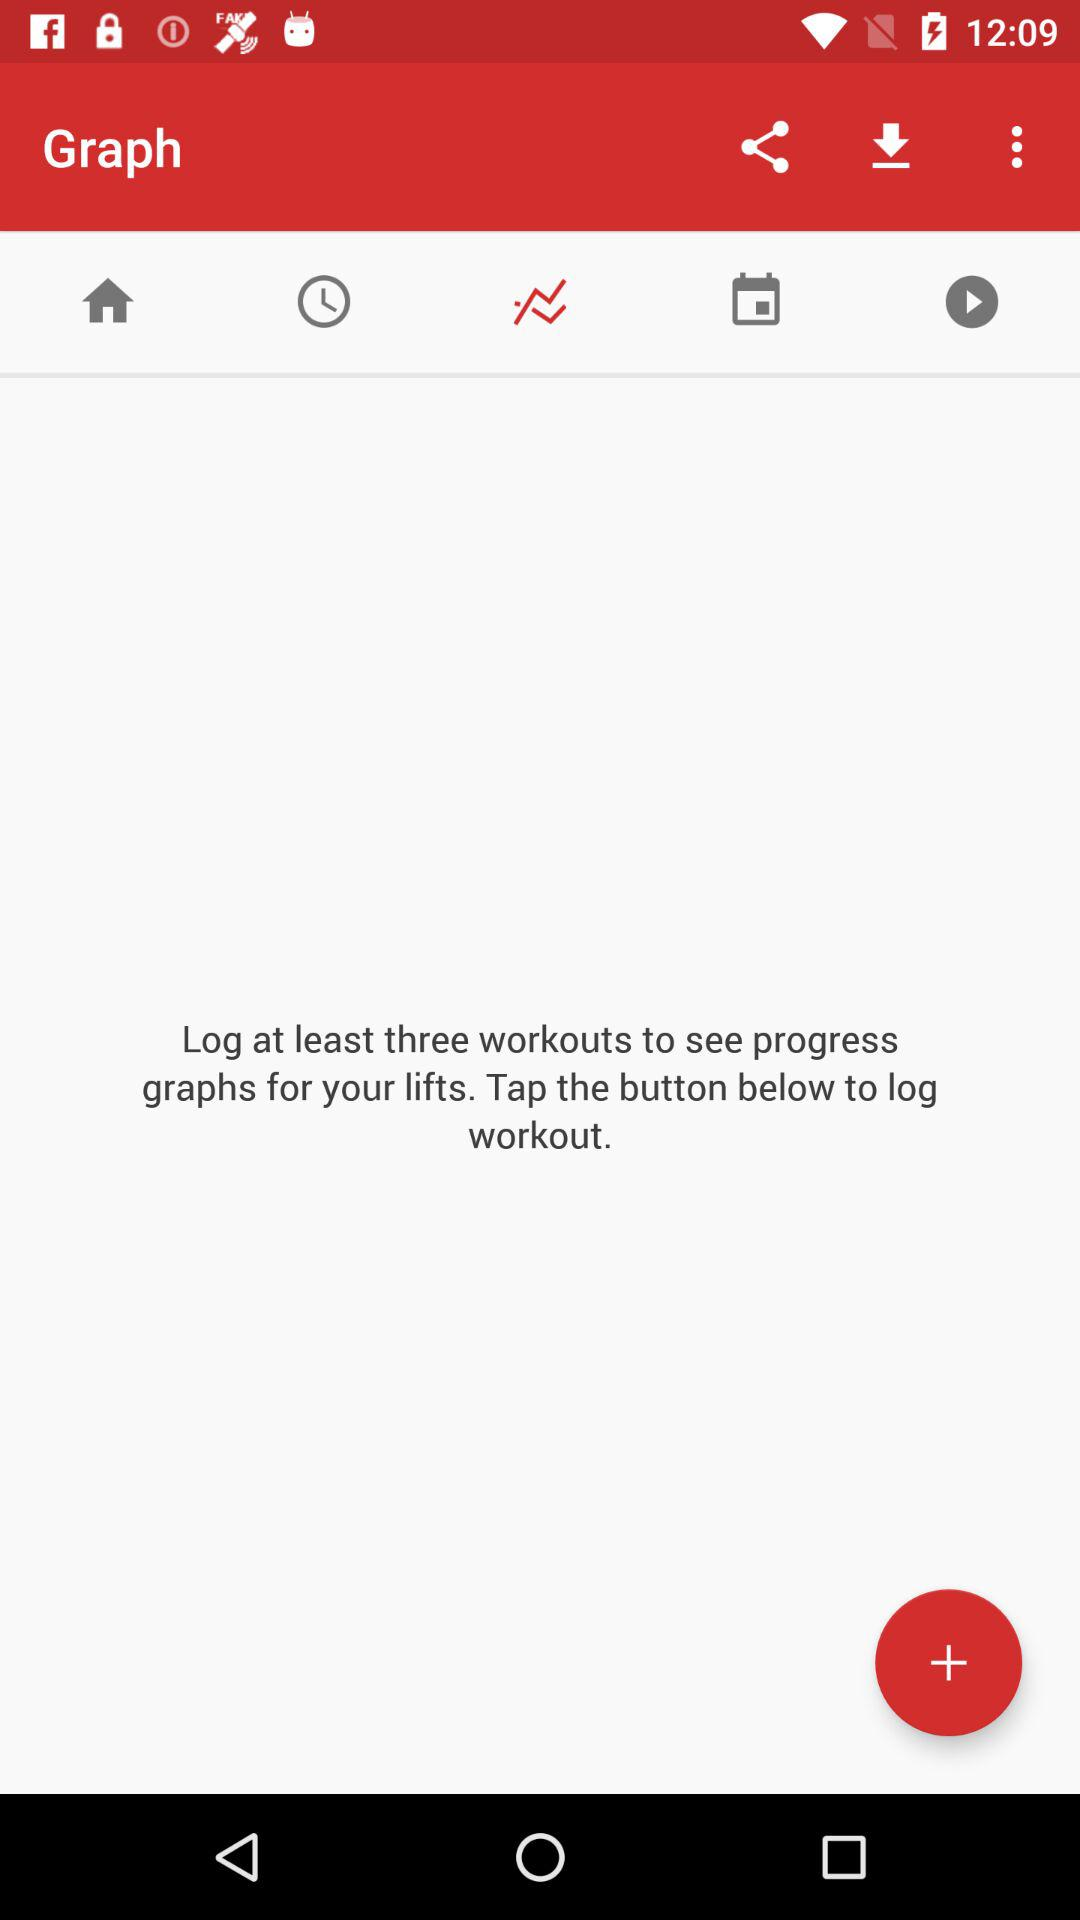How many more workout logs do I need to see graphs?
Answer the question using a single word or phrase. 3 